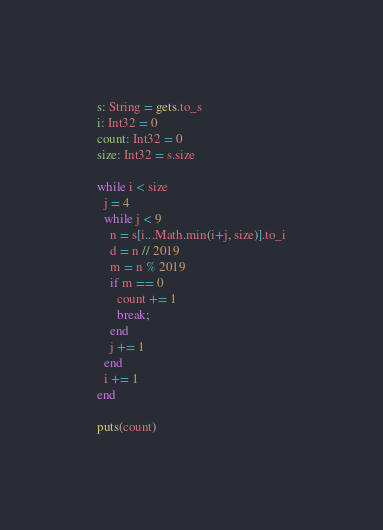Convert code to text. <code><loc_0><loc_0><loc_500><loc_500><_Crystal_>s: String = gets.to_s
i: Int32 = 0
count: Int32 = 0
size: Int32 = s.size

while i < size
  j = 4
  while j < 9
    n = s[i...Math.min(i+j, size)].to_i
    d = n // 2019
    m = n % 2019
    if m == 0
      count += 1
      break;
    end
    j += 1
  end
  i += 1
end

puts(count)</code> 